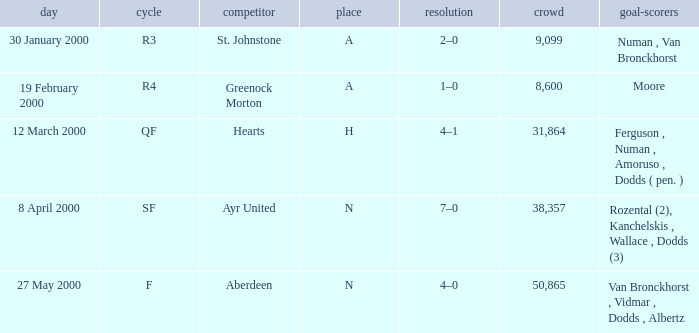What venue was on 27 May 2000? N. Help me parse the entirety of this table. {'header': ['day', 'cycle', 'competitor', 'place', 'resolution', 'crowd', 'goal-scorers'], 'rows': [['30 January 2000', 'R3', 'St. Johnstone', 'A', '2–0', '9,099', 'Numan , Van Bronckhorst'], ['19 February 2000', 'R4', 'Greenock Morton', 'A', '1–0', '8,600', 'Moore'], ['12 March 2000', 'QF', 'Hearts', 'H', '4–1', '31,864', 'Ferguson , Numan , Amoruso , Dodds ( pen. )'], ['8 April 2000', 'SF', 'Ayr United', 'N', '7–0', '38,357', 'Rozental (2), Kanchelskis , Wallace , Dodds (3)'], ['27 May 2000', 'F', 'Aberdeen', 'N', '4–0', '50,865', 'Van Bronckhorst , Vidmar , Dodds , Albertz']]} 